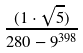<formula> <loc_0><loc_0><loc_500><loc_500>\frac { ( 1 \cdot \sqrt { 5 } ) } { 2 8 0 - 9 ^ { 3 9 8 } }</formula> 